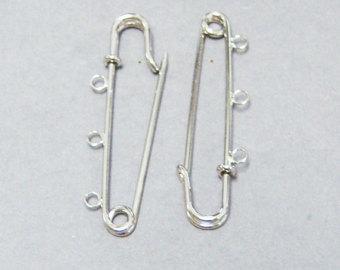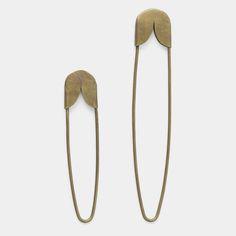The first image is the image on the left, the second image is the image on the right. Evaluate the accuracy of this statement regarding the images: "In one image, no less than three safety pins are arranged in order next to each other by size". Is it true? Answer yes or no. No. 